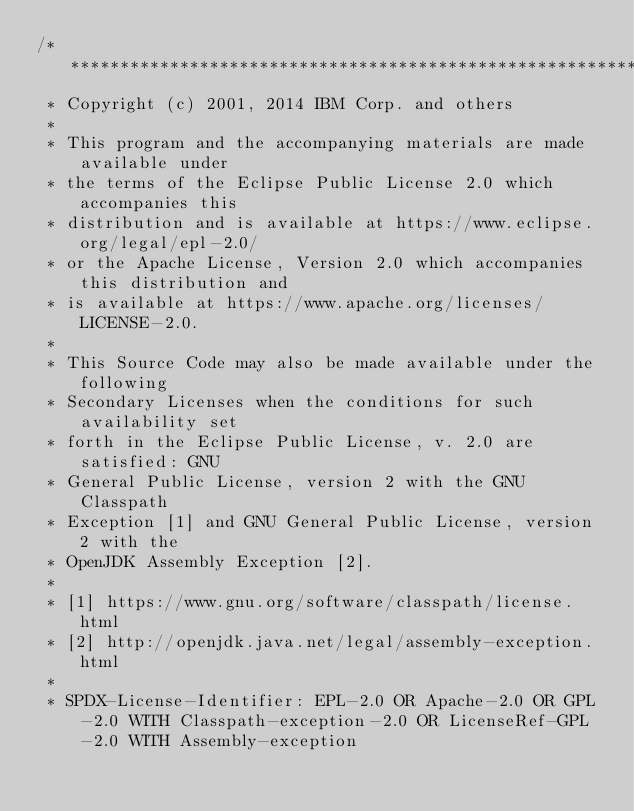<code> <loc_0><loc_0><loc_500><loc_500><_Java_>/*******************************************************************************
 * Copyright (c) 2001, 2014 IBM Corp. and others
 *
 * This program and the accompanying materials are made available under
 * the terms of the Eclipse Public License 2.0 which accompanies this
 * distribution and is available at https://www.eclipse.org/legal/epl-2.0/
 * or the Apache License, Version 2.0 which accompanies this distribution and
 * is available at https://www.apache.org/licenses/LICENSE-2.0.
 *
 * This Source Code may also be made available under the following
 * Secondary Licenses when the conditions for such availability set
 * forth in the Eclipse Public License, v. 2.0 are satisfied: GNU
 * General Public License, version 2 with the GNU Classpath
 * Exception [1] and GNU General Public License, version 2 with the
 * OpenJDK Assembly Exception [2].
 *
 * [1] https://www.gnu.org/software/classpath/license.html
 * [2] http://openjdk.java.net/legal/assembly-exception.html
 *
 * SPDX-License-Identifier: EPL-2.0 OR Apache-2.0 OR GPL-2.0 WITH Classpath-exception-2.0 OR LicenseRef-GPL-2.0 WITH Assembly-exception</code> 